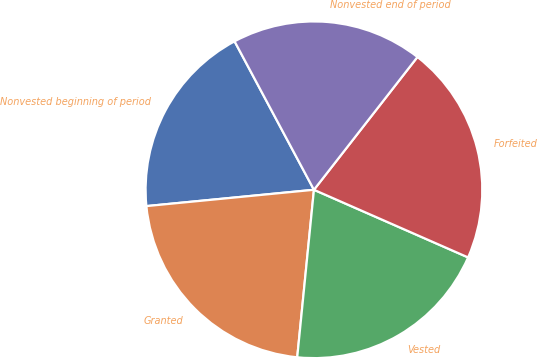Convert chart to OTSL. <chart><loc_0><loc_0><loc_500><loc_500><pie_chart><fcel>Nonvested beginning of period<fcel>Granted<fcel>Vested<fcel>Forfeited<fcel>Nonvested end of period<nl><fcel>18.73%<fcel>21.87%<fcel>20.0%<fcel>21.04%<fcel>18.35%<nl></chart> 